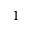Convert formula to latex. <formula><loc_0><loc_0><loc_500><loc_500>^ { 1 }</formula> 